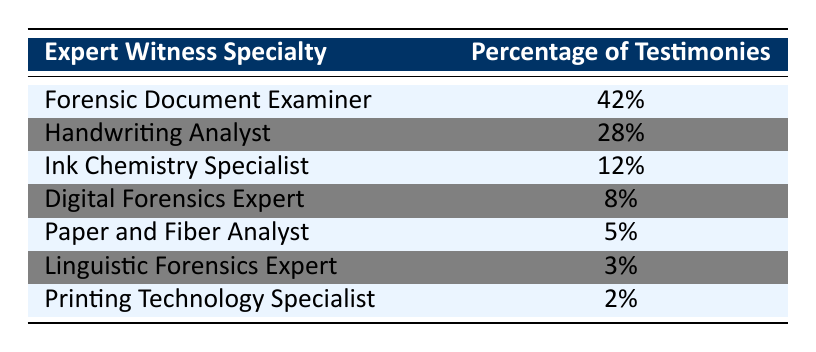What percentage of testimonies is provided by the Forensic Document Examiner? The table shows that the Forensic Document Examiner has a percentage listed next to it, which directly indicates their contribution. According to the data, it is 42%.
Answer: 42% Which expert witness specialty has the least percentage of testimonies? By scanning through the percentages, we find that the Printing Technology Specialist has the lowest figure of 2%.
Answer: 2% What is the combined percentage of testimonies from the Handwriting Analyst and the Ink Chemistry Specialist? To find this, we add the percentages of the Handwriting Analyst (28%) and the Ink Chemistry Specialist (12%): 28% + 12% = 40%.
Answer: 40% Is it true that the Digital Forensics Expert contributes more to testimonies than the Paper and Fiber Analyst? The Digital Forensics Expert has a percentage of 8%, while the Paper and Fiber Analyst has 5%. Since 8% is greater than 5%, the statement is true.
Answer: Yes What percentage of testimonies does the Linguistic Forensics Expert provide compared to the combined total of the Forensic Document Examiner and Handwriting Analyst? First, we find the percentage from the Linguistic Forensics Expert, which is 3%. Then we find the combined total of the Forensic Document Examiner (42%) and Handwriting Analyst (28%), which is 70%. To see how much 3% is of 70%, we note that 3% is significantly lower than 70%. Therefore, the Linguistic Forensics Expert represents a much smaller percentage than this combined total.
Answer: 3% What fraction of the testimonies comes from specialties other than Paper and Fiber Analyst and Printing Technology Specialist? The percentages of Paper and Fiber Analyst and Printing Technology Specialist are 5% and 2%, respectively. Total testimonies from these two are 5% + 2% = 7%. If we subtract this from the overall total (100%), we have 100% - 7% = 93%. Thus, 93% of testimonies come from other specialties.
Answer: 93% How many expert witness specialties have a percentage of less than 10%? By examining the table, we see Digital Forensics Expert (8%), Paper and Fiber Analyst (5%), Linguistic Forensics Expert (3%), and Printing Technology Specialist (2%) all fall below 10%. Counting these specialties gives us a total of 4.
Answer: 4 What is the ratio of testimonies between the Handwriting Analyst and Printing Technology Specialist? The Handwriting Analyst has 28% and the Printing Technology Specialist has 2%. To find the ratio, we divide 28% by 2%, which simplifies to 14:1. This means there are 14 times more testimonies from the Handwriting Analyst than the Printing Technology Specialist.
Answer: 14:1 